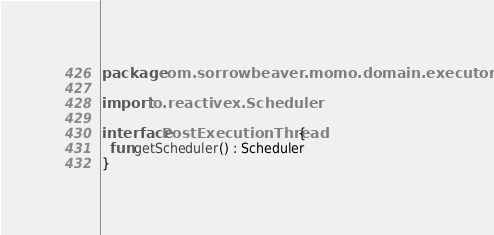Convert code to text. <code><loc_0><loc_0><loc_500><loc_500><_Kotlin_>package com.sorrowbeaver.momo.domain.executor

import io.reactivex.Scheduler

interface PostExecutionThread {
  fun getScheduler() : Scheduler
}
</code> 